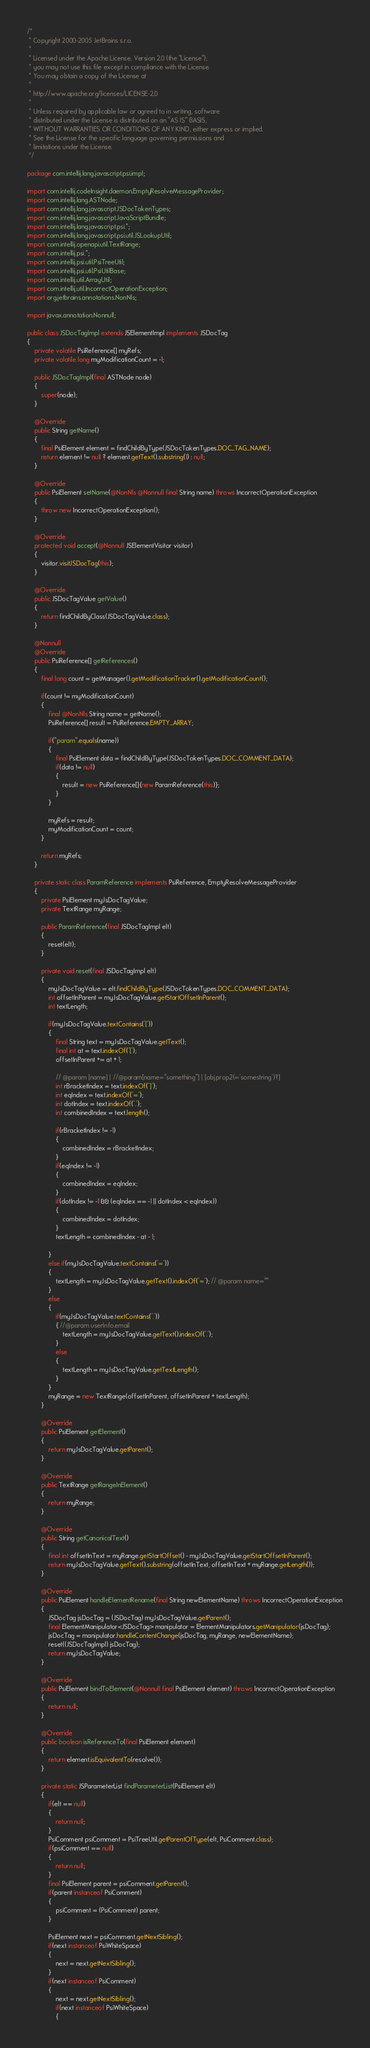<code> <loc_0><loc_0><loc_500><loc_500><_Java_>/*
 * Copyright 2000-2005 JetBrains s.r.o.
 *
 * Licensed under the Apache License, Version 2.0 (the "License");
 * you may not use this file except in compliance with the License.
 * You may obtain a copy of the License at
 *
 * http://www.apache.org/licenses/LICENSE-2.0
 *
 * Unless required by applicable law or agreed to in writing, software
 * distributed under the License is distributed on an "AS IS" BASIS,
 * WITHOUT WARRANTIES OR CONDITIONS OF ANY KIND, either express or implied.
 * See the License for the specific language governing permissions and
 * limitations under the License.
 */

package com.intellij.lang.javascript.psi.impl;

import com.intellij.codeInsight.daemon.EmptyResolveMessageProvider;
import com.intellij.lang.ASTNode;
import com.intellij.lang.javascript.JSDocTokenTypes;
import com.intellij.lang.javascript.JavaScriptBundle;
import com.intellij.lang.javascript.psi.*;
import com.intellij.lang.javascript.psi.util.JSLookupUtil;
import com.intellij.openapi.util.TextRange;
import com.intellij.psi.*;
import com.intellij.psi.util.PsiTreeUtil;
import com.intellij.psi.util.PsiUtilBase;
import com.intellij.util.ArrayUtil;
import com.intellij.util.IncorrectOperationException;
import org.jetbrains.annotations.NonNls;

import javax.annotation.Nonnull;

public class JSDocTagImpl extends JSElementImpl implements JSDocTag
{
	private volatile PsiReference[] myRefs;
	private volatile long myModificationCount = -1;

	public JSDocTagImpl(final ASTNode node)
	{
		super(node);
	}

	@Override
	public String getName()
	{
		final PsiElement element = findChildByType(JSDocTokenTypes.DOC_TAG_NAME);
		return element != null ? element.getText().substring(1) : null;
	}

	@Override
	public PsiElement setName(@NonNls @Nonnull final String name) throws IncorrectOperationException
	{
		throw new IncorrectOperationException();
	}

	@Override
	protected void accept(@Nonnull JSElementVisitor visitor)
	{
		visitor.visitJSDocTag(this);
	}

	@Override
	public JSDocTagValue getValue()
	{
		return findChildByClass(JSDocTagValue.class);
	}

	@Nonnull
	@Override
	public PsiReference[] getReferences()
	{
		final long count = getManager().getModificationTracker().getModificationCount();

		if(count != myModificationCount)
		{
			final @NonNls String name = getName();
			PsiReference[] result = PsiReference.EMPTY_ARRAY;

			if("param".equals(name))
			{
				final PsiElement data = findChildByType(JSDocTokenTypes.DOC_COMMENT_DATA);
				if(data != null)
				{
					result = new PsiReference[]{new ParamReference(this)};
				}
			}

			myRefs = result;
			myModificationCount = count;
		}

		return myRefs;
	}

	private static class ParamReference implements PsiReference, EmptyResolveMessageProvider
	{
		private PsiElement myJsDocTagValue;
		private TextRange myRange;

		public ParamReference(final JSDocTagImpl elt)
		{
			reset(elt);
		}

		private void reset(final JSDocTagImpl elt)
		{
			myJsDocTagValue = elt.findChildByType(JSDocTokenTypes.DOC_COMMENT_DATA);
			int offsetInParent = myJsDocTagValue.getStartOffsetInParent();
			int textLength;

			if(myJsDocTagValue.textContains('['))
			{
				final String text = myJsDocTagValue.getText();
				final int at = text.indexOf('[');
				offsetInParent += at + 1;

				// @param [name] | //@param[name="something"] | [obj.prop2(='somestring')?]
				int rBracketIndex = text.indexOf(']');
				int eqIndex = text.indexOf('=');
				int dotIndex = text.indexOf('.');
				int combinedIndex = text.length();

				if(rBracketIndex != -1)
				{
					combinedIndex = rBracketIndex;
				}
				if(eqIndex != -1)
				{
					combinedIndex = eqIndex;
				}
				if(dotIndex != -1 && (eqIndex == -1 || dotIndex < eqIndex))
				{
					combinedIndex = dotIndex;
				}
				textLength = combinedIndex - at - 1;

			}
			else if(myJsDocTagValue.textContains('='))
			{
				textLength = myJsDocTagValue.getText().indexOf('='); // @param name=""
			}
			else
			{
				if(myJsDocTagValue.textContains('.'))
				{ //@param userInfo.email
					textLength = myJsDocTagValue.getText().indexOf('.');
				}
				else
				{
					textLength = myJsDocTagValue.getTextLength();
				}
			}
			myRange = new TextRange(offsetInParent, offsetInParent + textLength);
		}

		@Override
		public PsiElement getElement()
		{
			return myJsDocTagValue.getParent();
		}

		@Override
		public TextRange getRangeInElement()
		{
			return myRange;
		}

		@Override
		public String getCanonicalText()
		{
			final int offsetInText = myRange.getStartOffset() - myJsDocTagValue.getStartOffsetInParent();
			return myJsDocTagValue.getText().substring(offsetInText, offsetInText + myRange.getLength());
		}

		@Override
		public PsiElement handleElementRename(final String newElementName) throws IncorrectOperationException
		{
			JSDocTag jsDocTag = (JSDocTag) myJsDocTagValue.getParent();
			final ElementManipulator<JSDocTag> manipulator = ElementManipulators.getManipulator(jsDocTag);
			jsDocTag = manipulator.handleContentChange(jsDocTag, myRange, newElementName);
			reset((JSDocTagImpl) jsDocTag);
			return myJsDocTagValue;
		}

		@Override
		public PsiElement bindToElement(@Nonnull final PsiElement element) throws IncorrectOperationException
		{
			return null;
		}

		@Override
		public boolean isReferenceTo(final PsiElement element)
		{
			return element.isEquivalentTo(resolve());
		}

		private static JSParameterList findParameterList(PsiElement elt)
		{
			if(elt == null)
			{
				return null;
			}
			PsiComment psiComment = PsiTreeUtil.getParentOfType(elt, PsiComment.class);
			if(psiComment == null)
			{
				return null;
			}
			final PsiElement parent = psiComment.getParent();
			if(parent instanceof PsiComment)
			{
				psiComment = (PsiComment) parent;
			}

			PsiElement next = psiComment.getNextSibling();
			if(next instanceof PsiWhiteSpace)
			{
				next = next.getNextSibling();
			}
			if(next instanceof PsiComment)
			{
				next = next.getNextSibling();
				if(next instanceof PsiWhiteSpace)
				{</code> 